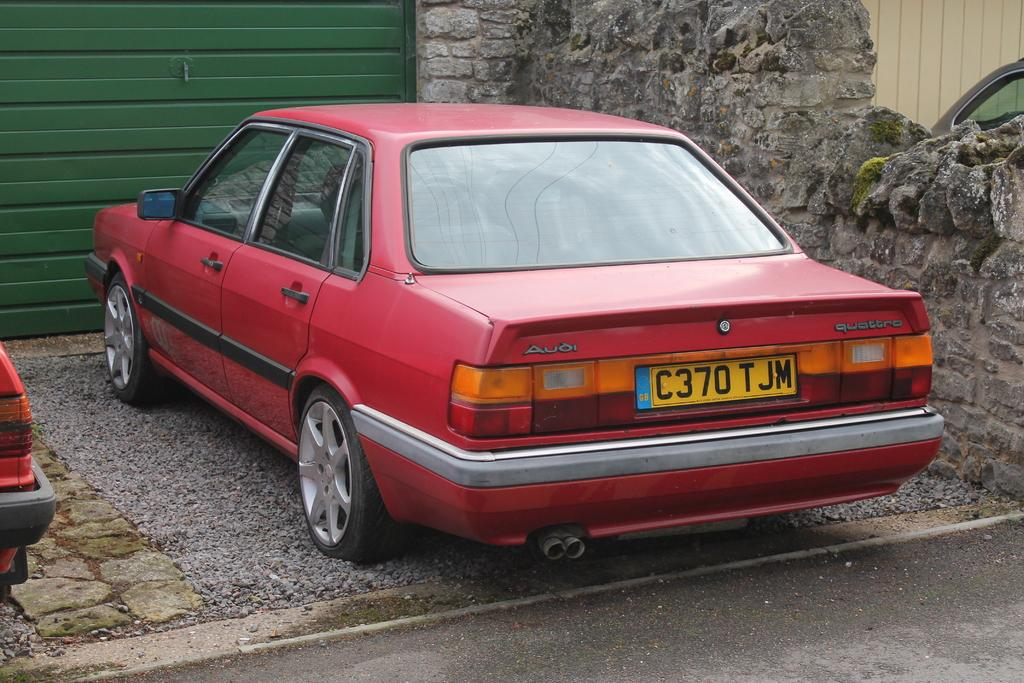What is the main subject in the middle of the image? There is a car in the middle of the image. What is blocking the car in the image? There is a shutter in front of the car. What can be seen to the side of the car? There is a wall visible to the side of the car. How many vehicles are present in the image? There are two vehicles in the image. What type of camera is the person using to take a picture of the car in the image? There is no person or camera present in the image; it only shows a car with a shutter in front of it and a wall to the side. 